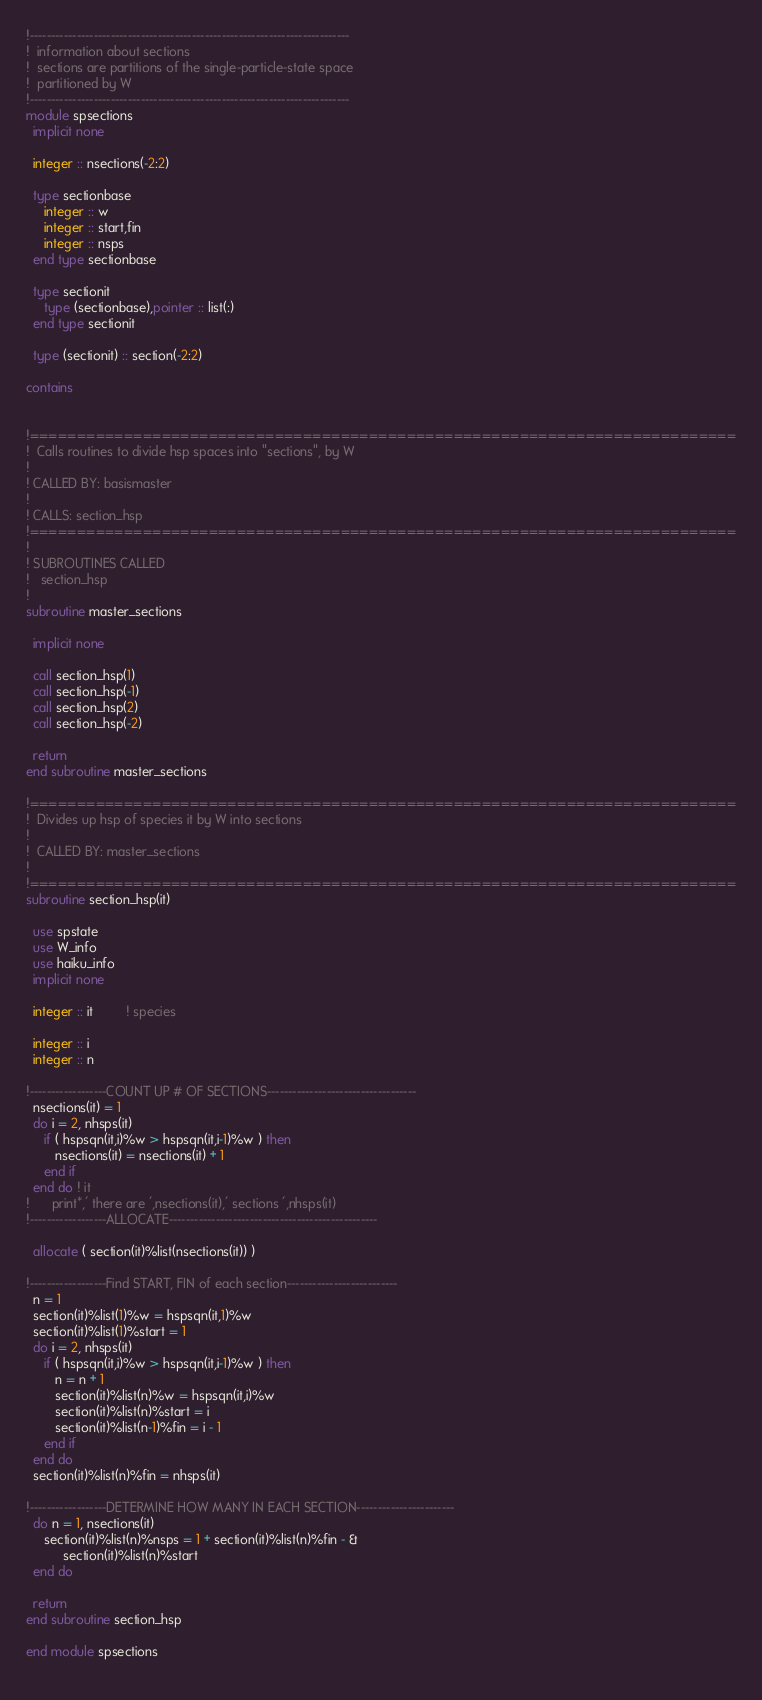<code> <loc_0><loc_0><loc_500><loc_500><_FORTRAN_>!---------------------------------------------------------------------------
!  information about sections
!  sections are partitions of the single-particle-state space
!  partitioned by W
!---------------------------------------------------------------------------
module spsections
  implicit none

  integer :: nsections(-2:2)

  type sectionbase
     integer :: w
     integer :: start,fin
     integer :: nsps   
  end type sectionbase

  type sectionit
     type (sectionbase),pointer :: list(:)
  end type sectionit

  type (sectionit) :: section(-2:2)

contains
	

!===========================================================================
!  Calls routines to divide hsp spaces into "sections", by W
!
! CALLED BY: basismaster
!
! CALLS: section_hsp
!===========================================================================
!
! SUBROUTINES CALLED
!	section_hsp
!
subroutine master_sections

  implicit none
  
  call section_hsp(1)
  call section_hsp(-1)
  call section_hsp(2)
  call section_hsp(-2)

  return
end subroutine master_sections
      
!===========================================================================
!  Divides up hsp of species it by W into sections
!
!  CALLED BY: master_sections
!
!===========================================================================
subroutine section_hsp(it)

  use spstate
  use W_info
  use haiku_info
  implicit none
  
  integer :: it         ! species

  integer :: i
  integer :: n
  
!------------------COUNT UP # OF SECTIONS-----------------------------------
  nsections(it) = 1
  do i = 2, nhsps(it)
     if ( hspsqn(it,i)%w > hspsqn(it,i-1)%w ) then
        nsections(it) = nsections(it) + 1
     end if
  end do ! it
!      print*,' there are ',nsections(it),' sections ',nhsps(it)
!------------------ALLOCATE-------------------------------------------------

  allocate ( section(it)%list(nsections(it)) )

!------------------Find START, FIN of each section--------------------------
  n = 1
  section(it)%list(1)%w = hspsqn(it,1)%w
  section(it)%list(1)%start = 1
  do i = 2, nhsps(it)
     if ( hspsqn(it,i)%w > hspsqn(it,i-1)%w ) then
        n = n + 1
        section(it)%list(n)%w = hspsqn(it,i)%w
        section(it)%list(n)%start = i
        section(it)%list(n-1)%fin = i - 1
     end if
  end do
  section(it)%list(n)%fin = nhsps(it)

!------------------DETERMINE HOW MANY IN EACH SECTION-----------------------
  do n = 1, nsections(it)
     section(it)%list(n)%nsps = 1 + section(it)%list(n)%fin - &
          section(it)%list(n)%start
  end do

  return
end subroutine section_hsp

end module spsections
  
</code> 